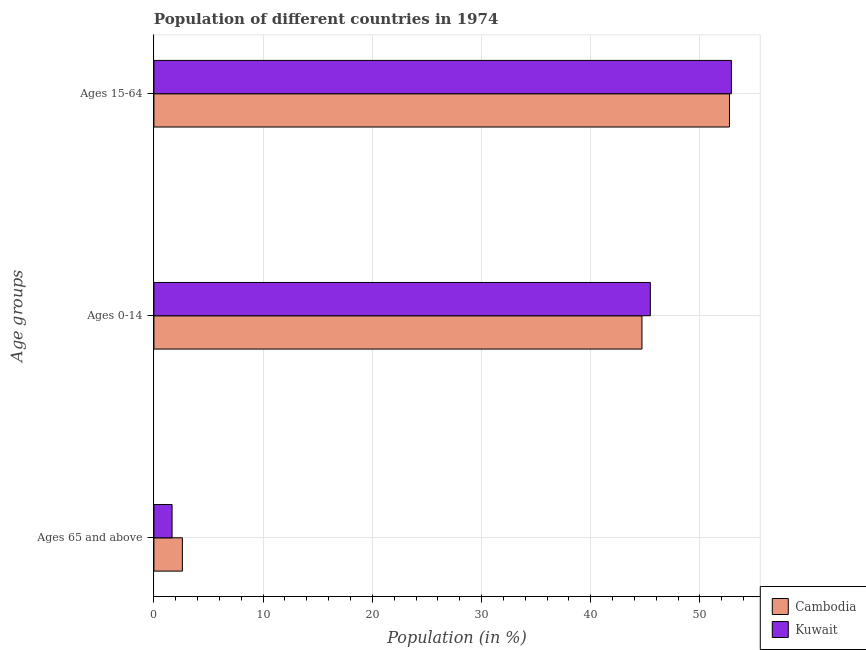How many groups of bars are there?
Give a very brief answer. 3. Are the number of bars per tick equal to the number of legend labels?
Your response must be concise. Yes. Are the number of bars on each tick of the Y-axis equal?
Your response must be concise. Yes. How many bars are there on the 3rd tick from the bottom?
Your answer should be very brief. 2. What is the label of the 3rd group of bars from the top?
Offer a very short reply. Ages 65 and above. What is the percentage of population within the age-group of 65 and above in Kuwait?
Make the answer very short. 1.66. Across all countries, what is the maximum percentage of population within the age-group 15-64?
Ensure brevity in your answer.  52.88. Across all countries, what is the minimum percentage of population within the age-group 15-64?
Offer a terse response. 52.7. In which country was the percentage of population within the age-group 15-64 maximum?
Your answer should be very brief. Kuwait. In which country was the percentage of population within the age-group 0-14 minimum?
Your answer should be compact. Cambodia. What is the total percentage of population within the age-group 15-64 in the graph?
Keep it short and to the point. 105.58. What is the difference between the percentage of population within the age-group 15-64 in Kuwait and that in Cambodia?
Your response must be concise. 0.18. What is the difference between the percentage of population within the age-group of 65 and above in Cambodia and the percentage of population within the age-group 0-14 in Kuwait?
Make the answer very short. -42.85. What is the average percentage of population within the age-group 15-64 per country?
Give a very brief answer. 52.79. What is the difference between the percentage of population within the age-group of 65 and above and percentage of population within the age-group 0-14 in Kuwait?
Your response must be concise. -43.8. In how many countries, is the percentage of population within the age-group of 65 and above greater than 30 %?
Provide a short and direct response. 0. What is the ratio of the percentage of population within the age-group of 65 and above in Kuwait to that in Cambodia?
Your answer should be very brief. 0.64. Is the percentage of population within the age-group 0-14 in Cambodia less than that in Kuwait?
Keep it short and to the point. Yes. Is the difference between the percentage of population within the age-group 0-14 in Cambodia and Kuwait greater than the difference between the percentage of population within the age-group 15-64 in Cambodia and Kuwait?
Your response must be concise. No. What is the difference between the highest and the second highest percentage of population within the age-group of 65 and above?
Offer a terse response. 0.95. What is the difference between the highest and the lowest percentage of population within the age-group 0-14?
Your answer should be compact. 0.77. In how many countries, is the percentage of population within the age-group of 65 and above greater than the average percentage of population within the age-group of 65 and above taken over all countries?
Keep it short and to the point. 1. Is the sum of the percentage of population within the age-group 0-14 in Cambodia and Kuwait greater than the maximum percentage of population within the age-group 15-64 across all countries?
Your response must be concise. Yes. What does the 2nd bar from the top in Ages 15-64 represents?
Your answer should be very brief. Cambodia. What does the 2nd bar from the bottom in Ages 65 and above represents?
Offer a terse response. Kuwait. Is it the case that in every country, the sum of the percentage of population within the age-group of 65 and above and percentage of population within the age-group 0-14 is greater than the percentage of population within the age-group 15-64?
Your response must be concise. No. How many bars are there?
Offer a terse response. 6. How many countries are there in the graph?
Keep it short and to the point. 2. Are the values on the major ticks of X-axis written in scientific E-notation?
Give a very brief answer. No. Does the graph contain grids?
Keep it short and to the point. Yes. Where does the legend appear in the graph?
Make the answer very short. Bottom right. What is the title of the graph?
Provide a succinct answer. Population of different countries in 1974. What is the label or title of the X-axis?
Offer a very short reply. Population (in %). What is the label or title of the Y-axis?
Ensure brevity in your answer.  Age groups. What is the Population (in %) in Cambodia in Ages 65 and above?
Offer a terse response. 2.61. What is the Population (in %) in Kuwait in Ages 65 and above?
Give a very brief answer. 1.66. What is the Population (in %) in Cambodia in Ages 0-14?
Give a very brief answer. 44.69. What is the Population (in %) in Kuwait in Ages 0-14?
Offer a terse response. 45.46. What is the Population (in %) in Cambodia in Ages 15-64?
Your answer should be very brief. 52.7. What is the Population (in %) in Kuwait in Ages 15-64?
Provide a succinct answer. 52.88. Across all Age groups, what is the maximum Population (in %) of Cambodia?
Give a very brief answer. 52.7. Across all Age groups, what is the maximum Population (in %) of Kuwait?
Your answer should be very brief. 52.88. Across all Age groups, what is the minimum Population (in %) of Cambodia?
Offer a terse response. 2.61. Across all Age groups, what is the minimum Population (in %) in Kuwait?
Your answer should be very brief. 1.66. What is the total Population (in %) in Kuwait in the graph?
Offer a very short reply. 100. What is the difference between the Population (in %) of Cambodia in Ages 65 and above and that in Ages 0-14?
Offer a terse response. -42.08. What is the difference between the Population (in %) in Kuwait in Ages 65 and above and that in Ages 0-14?
Provide a short and direct response. -43.8. What is the difference between the Population (in %) in Cambodia in Ages 65 and above and that in Ages 15-64?
Your answer should be compact. -50.1. What is the difference between the Population (in %) of Kuwait in Ages 65 and above and that in Ages 15-64?
Your answer should be very brief. -51.22. What is the difference between the Population (in %) of Cambodia in Ages 0-14 and that in Ages 15-64?
Provide a short and direct response. -8.01. What is the difference between the Population (in %) of Kuwait in Ages 0-14 and that in Ages 15-64?
Make the answer very short. -7.42. What is the difference between the Population (in %) of Cambodia in Ages 65 and above and the Population (in %) of Kuwait in Ages 0-14?
Provide a short and direct response. -42.85. What is the difference between the Population (in %) in Cambodia in Ages 65 and above and the Population (in %) in Kuwait in Ages 15-64?
Give a very brief answer. -50.27. What is the difference between the Population (in %) in Cambodia in Ages 0-14 and the Population (in %) in Kuwait in Ages 15-64?
Your answer should be very brief. -8.19. What is the average Population (in %) in Cambodia per Age groups?
Give a very brief answer. 33.33. What is the average Population (in %) in Kuwait per Age groups?
Offer a very short reply. 33.33. What is the difference between the Population (in %) of Cambodia and Population (in %) of Kuwait in Ages 65 and above?
Provide a succinct answer. 0.95. What is the difference between the Population (in %) in Cambodia and Population (in %) in Kuwait in Ages 0-14?
Offer a very short reply. -0.77. What is the difference between the Population (in %) of Cambodia and Population (in %) of Kuwait in Ages 15-64?
Give a very brief answer. -0.18. What is the ratio of the Population (in %) of Cambodia in Ages 65 and above to that in Ages 0-14?
Keep it short and to the point. 0.06. What is the ratio of the Population (in %) of Kuwait in Ages 65 and above to that in Ages 0-14?
Offer a terse response. 0.04. What is the ratio of the Population (in %) of Cambodia in Ages 65 and above to that in Ages 15-64?
Ensure brevity in your answer.  0.05. What is the ratio of the Population (in %) in Kuwait in Ages 65 and above to that in Ages 15-64?
Provide a succinct answer. 0.03. What is the ratio of the Population (in %) in Cambodia in Ages 0-14 to that in Ages 15-64?
Keep it short and to the point. 0.85. What is the ratio of the Population (in %) of Kuwait in Ages 0-14 to that in Ages 15-64?
Provide a short and direct response. 0.86. What is the difference between the highest and the second highest Population (in %) in Cambodia?
Provide a short and direct response. 8.01. What is the difference between the highest and the second highest Population (in %) of Kuwait?
Your answer should be compact. 7.42. What is the difference between the highest and the lowest Population (in %) of Cambodia?
Make the answer very short. 50.1. What is the difference between the highest and the lowest Population (in %) in Kuwait?
Offer a very short reply. 51.22. 